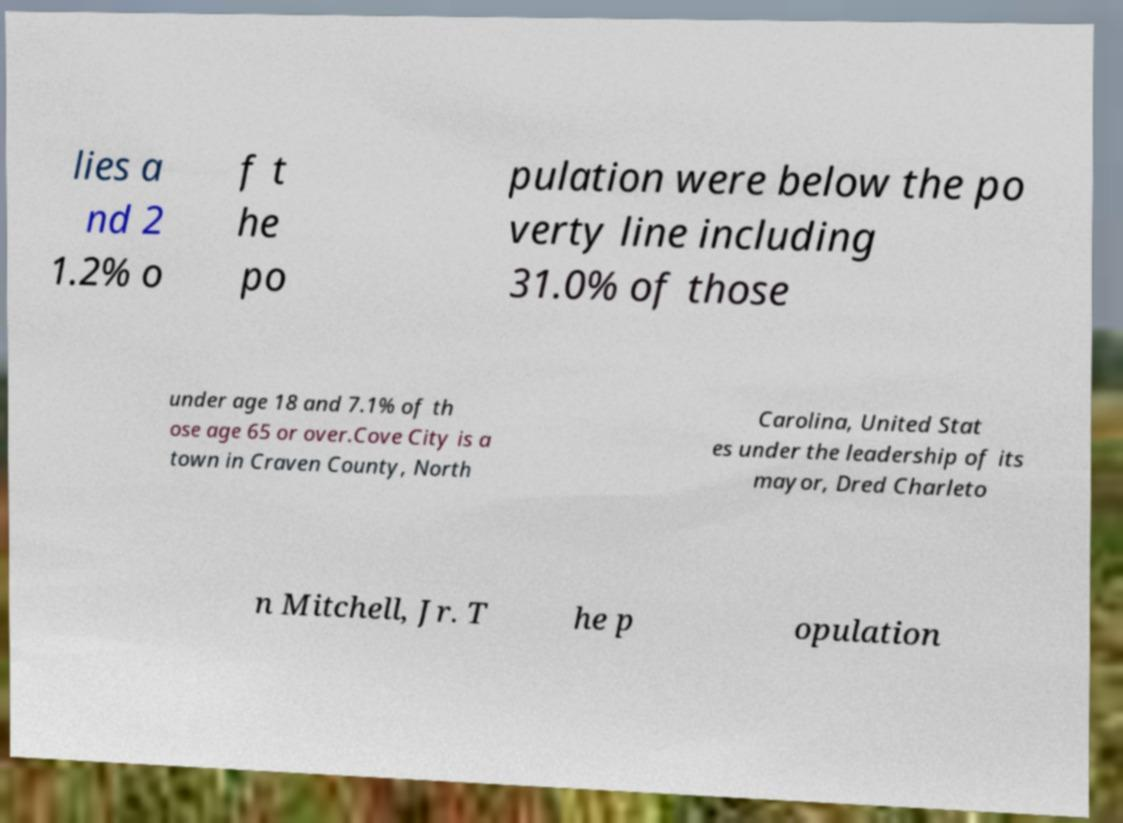Please read and relay the text visible in this image. What does it say? lies a nd 2 1.2% o f t he po pulation were below the po verty line including 31.0% of those under age 18 and 7.1% of th ose age 65 or over.Cove City is a town in Craven County, North Carolina, United Stat es under the leadership of its mayor, Dred Charleto n Mitchell, Jr. T he p opulation 